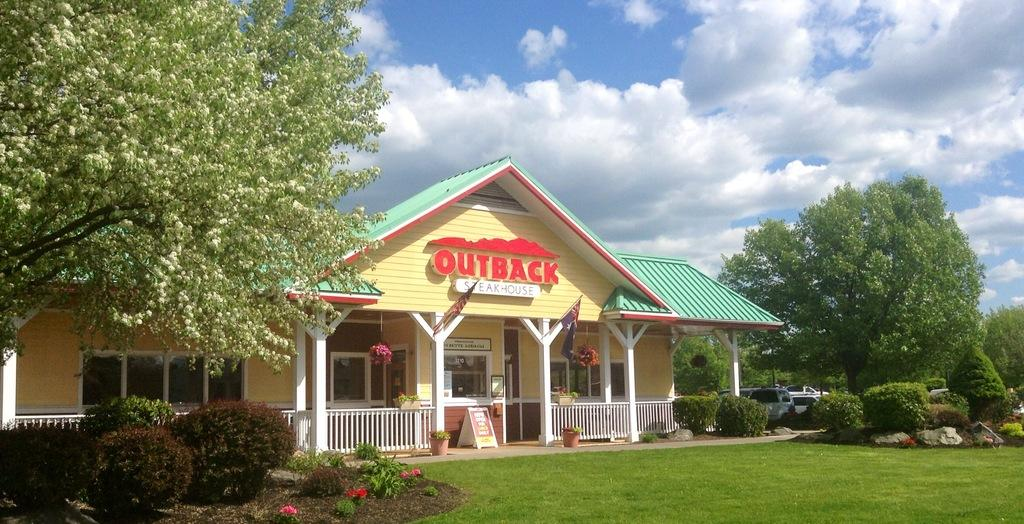What type of landscape is depicted in the image? There is a grassland in the image. What can be seen in the background of the grassland? There are trees, a house, cars, and the sky visible in the background of the image. Where is the yam growing in the image? There is no yam present in the image. What type of flag is visible on the swing in the image? There is no flag or swing present in the image. 